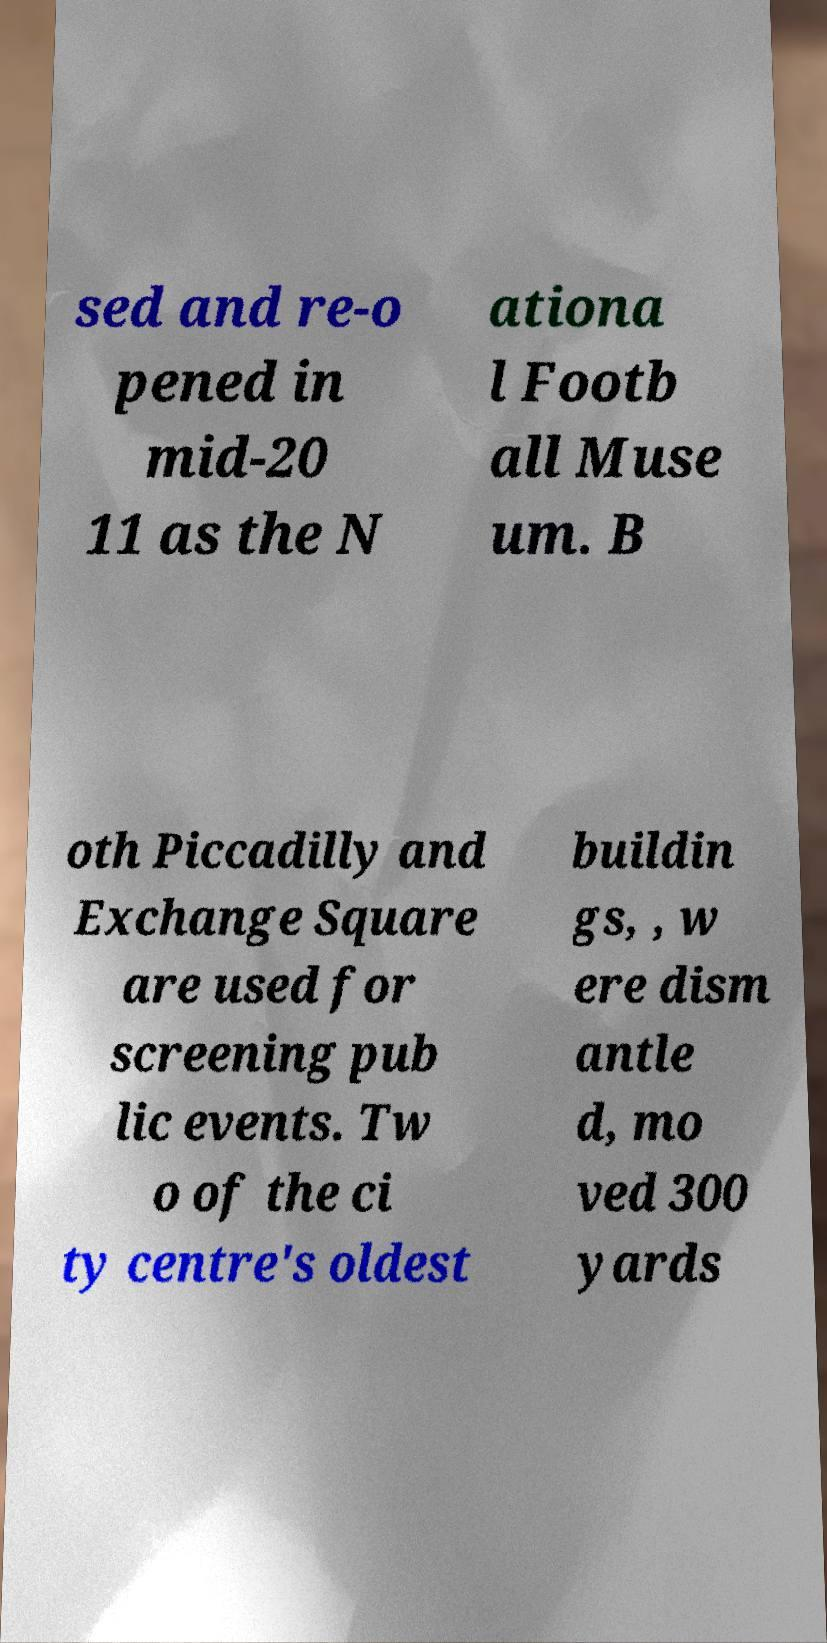Please identify and transcribe the text found in this image. sed and re-o pened in mid-20 11 as the N ationa l Footb all Muse um. B oth Piccadilly and Exchange Square are used for screening pub lic events. Tw o of the ci ty centre's oldest buildin gs, , w ere dism antle d, mo ved 300 yards 